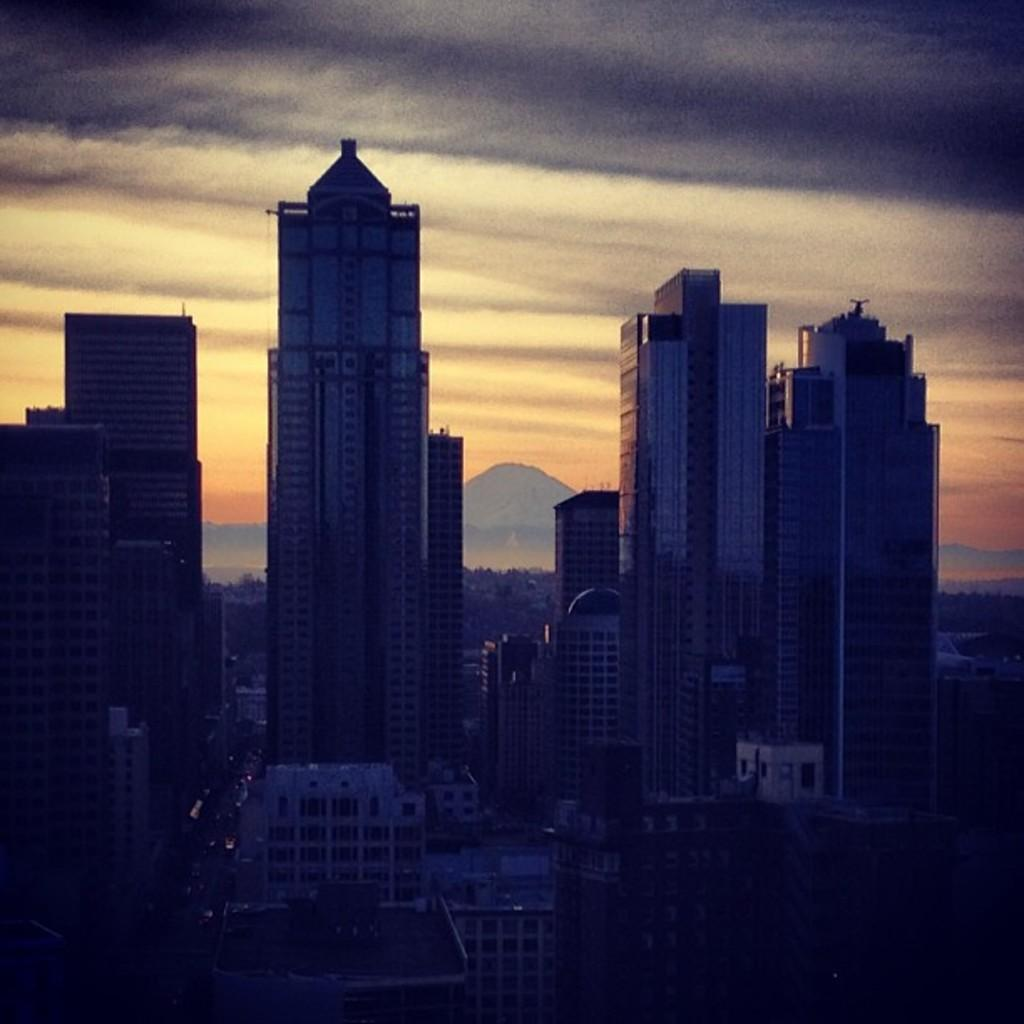What type of structures can be seen in the image? There are buildings in the image. What is visible in the background of the image? There is sky and mountains visible in the background of the image. What type of rod is being used to pump water in the image? There is no rod or pump present in the image. What type of vest is being worn by the person in the image? There is no person or vest present in the image. 